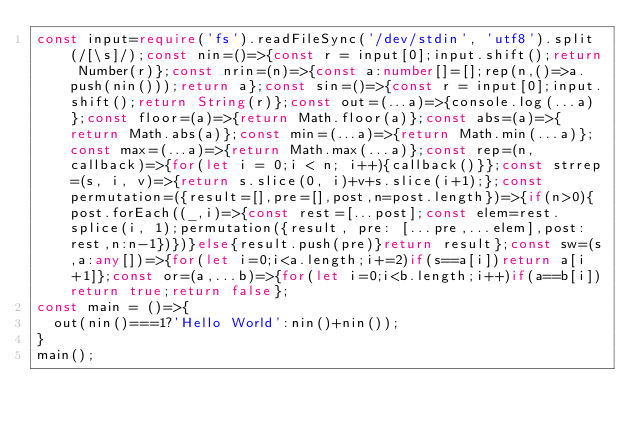<code> <loc_0><loc_0><loc_500><loc_500><_TypeScript_>const input=require('fs').readFileSync('/dev/stdin', 'utf8').split(/[\s]/);const nin=()=>{const r = input[0];input.shift();return Number(r)};const nrin=(n)=>{const a:number[]=[];rep(n,()=>a.push(nin()));return a};const sin=()=>{const r = input[0];input.shift();return String(r)};const out=(...a)=>{console.log(...a)};const floor=(a)=>{return Math.floor(a)};const abs=(a)=>{return Math.abs(a)};const min=(...a)=>{return Math.min(...a)};const max=(...a)=>{return Math.max(...a)};const rep=(n, callback)=>{for(let i = 0;i < n; i++){callback()}};const strrep=(s, i, v)=>{return s.slice(0, i)+v+s.slice(i+1);};const permutation=({result=[],pre=[],post,n=post.length})=>{if(n>0){post.forEach((_,i)=>{const rest=[...post];const elem=rest.splice(i, 1);permutation({result, pre: [...pre,...elem],post:rest,n:n-1})})}else{result.push(pre)}return result};const sw=(s,a:any[])=>{for(let i=0;i<a.length;i+=2)if(s==a[i])return a[i+1]};const or=(a,...b)=>{for(let i=0;i<b.length;i++)if(a==b[i])return true;return false};
const main = ()=>{
  out(nin()===1?'Hello World':nin()+nin());
}
main();</code> 